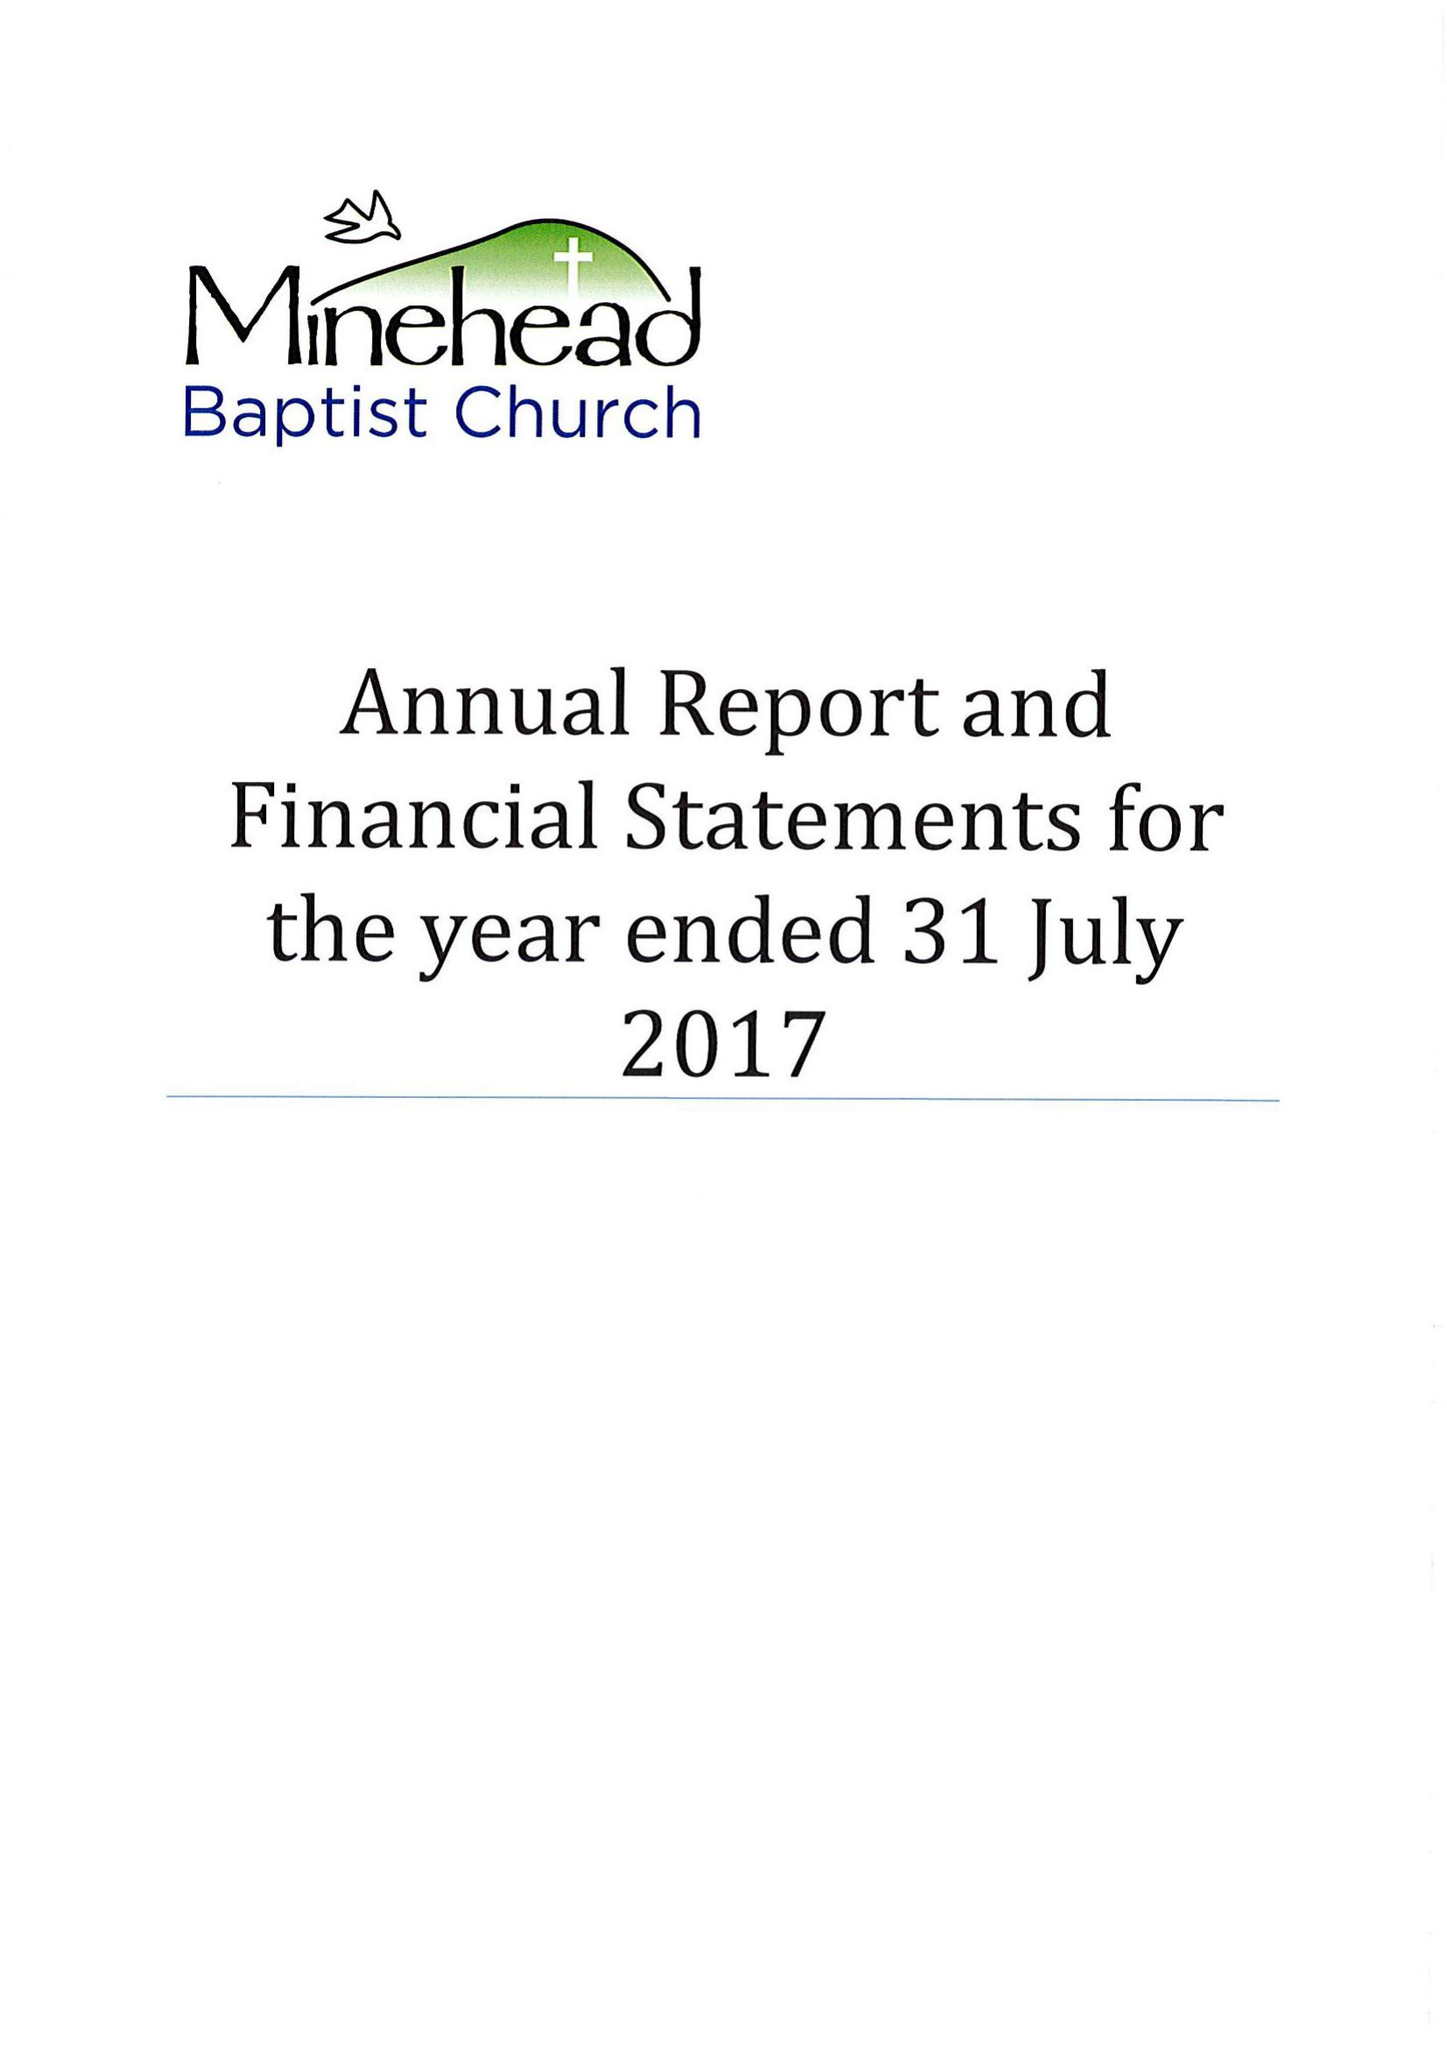What is the value for the report_date?
Answer the question using a single word or phrase. 2017-07-31 